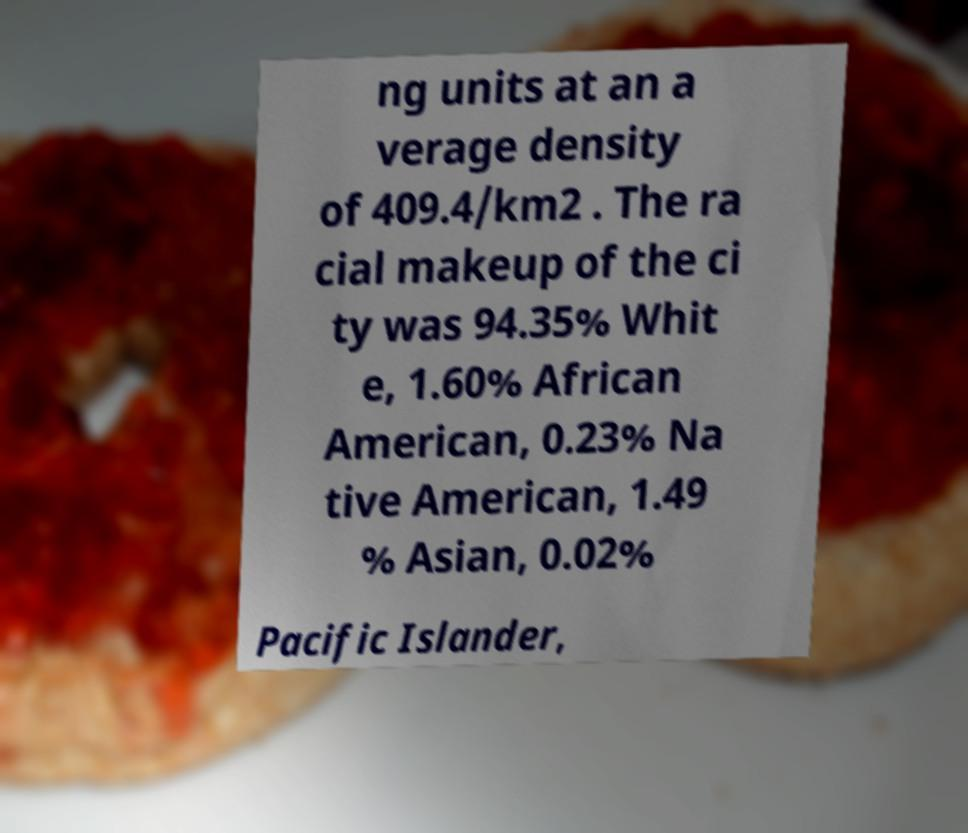Could you assist in decoding the text presented in this image and type it out clearly? ng units at an a verage density of 409.4/km2 . The ra cial makeup of the ci ty was 94.35% Whit e, 1.60% African American, 0.23% Na tive American, 1.49 % Asian, 0.02% Pacific Islander, 